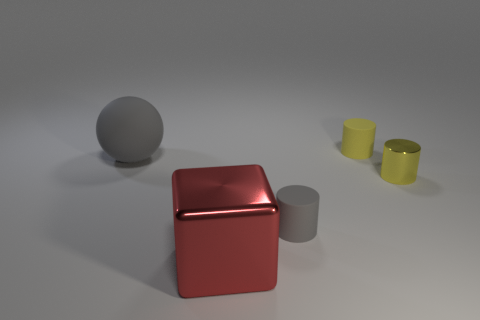There is a gray object that is the same size as the red metal cube; what is it made of?
Your answer should be compact. Rubber. There is a thing that is both on the left side of the tiny gray matte cylinder and behind the yellow metal cylinder; what size is it?
Keep it short and to the point. Large. How many things are either large rubber cylinders or big objects behind the gray cylinder?
Your response must be concise. 1. What is the shape of the big red object?
Give a very brief answer. Cube. There is a yellow object that is in front of the gray ball behind the gray rubber cylinder; what shape is it?
Give a very brief answer. Cylinder. What color is the cylinder that is made of the same material as the large red object?
Ensure brevity in your answer.  Yellow. There is a rubber thing to the left of the red cube; does it have the same color as the small matte object that is in front of the large gray thing?
Your response must be concise. Yes. Is the number of yellow rubber cylinders that are to the left of the tiny gray rubber object greater than the number of rubber balls on the left side of the large matte ball?
Your response must be concise. No. There is a metallic thing that is the same shape as the tiny yellow matte thing; what is its color?
Offer a terse response. Yellow. Is there anything else that has the same shape as the big gray object?
Ensure brevity in your answer.  No. 